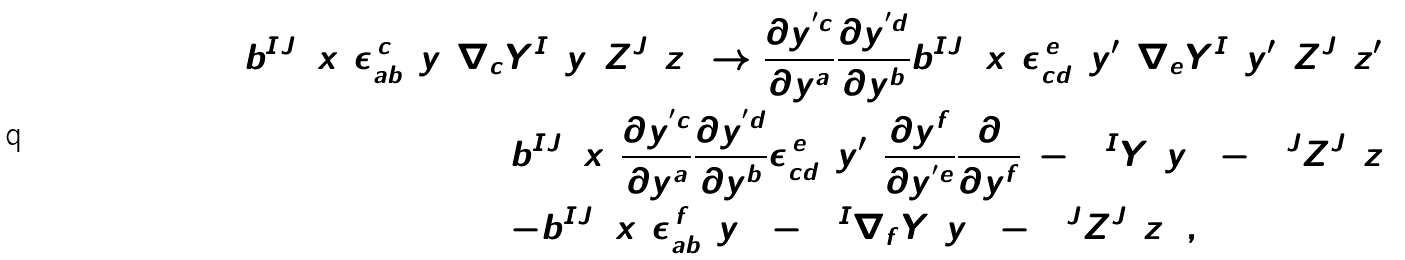<formula> <loc_0><loc_0><loc_500><loc_500>b _ { ( 1 ) } ^ { I J } ( x ) \epsilon _ { a b } ^ { \, c } ( y ) & \nabla _ { c } Y ^ { I } ( y ) Z ^ { J } ( z ) \rightarrow \frac { \partial y ^ { ^ { \prime } c } } { \partial y ^ { a } } \frac { \partial y ^ { ^ { \prime } d } } { \partial y ^ { b } } b _ { ( 1 ) } ^ { I J } ( x ) { \epsilon } _ { c d } ^ { \, e } ( y ^ { \prime } ) \nabla _ { e } Y ^ { I } ( y ^ { \prime } ) Z ^ { J } ( z ^ { \prime } ) \\ & = b _ { ( 1 ) } ^ { I J } ( x ) \frac { \partial y ^ { ^ { \prime } c } } { \partial y ^ { a } } \frac { \partial y ^ { ^ { \prime } d } } { \partial y ^ { b } } { \epsilon } _ { c d } ^ { \, e } ( y ^ { \prime } ) \frac { \partial y ^ { f } } { \partial y ^ { ^ { \prime } e } } \frac { \partial } { \partial y ^ { f } } ( - 1 ) ^ { I } Y ( y ) ( - 1 ) ^ { J } Z ^ { J } ( z ) \\ & = - b _ { ( 1 ) } ^ { I J } ( x ) \epsilon _ { a b } ^ { \, f } ( y ) ( - 1 ) ^ { I } \nabla _ { f } Y ( y ) ( - 1 ) ^ { J } Z ^ { J } ( z ) \, ,</formula> 